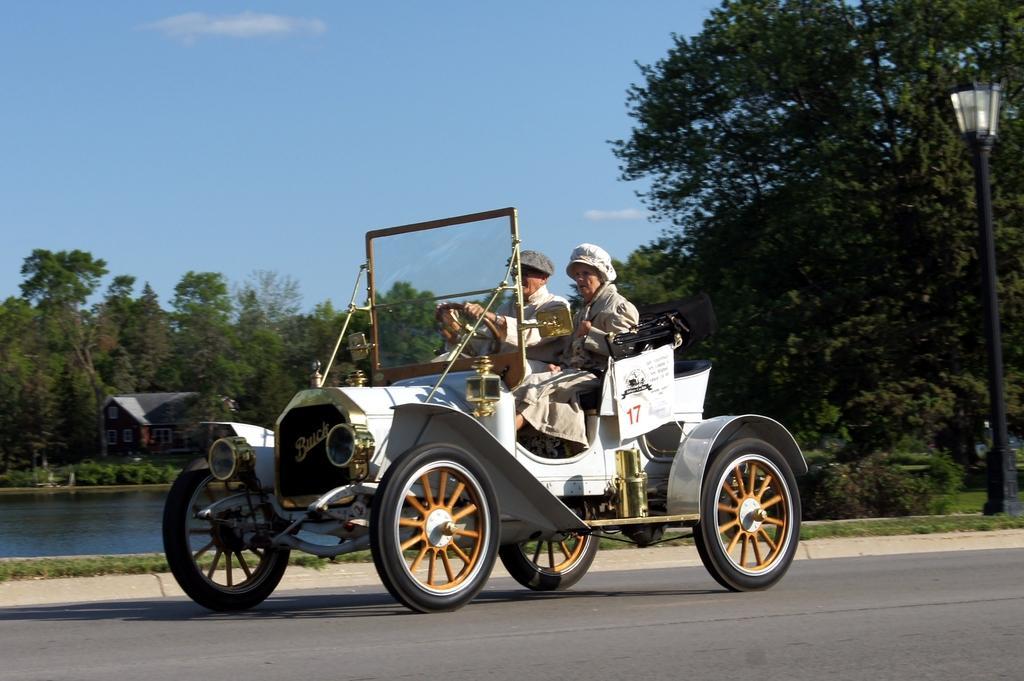Describe this image in one or two sentences. In the center of the image there is a vehicle and we can see a man and a lady sitting in the vehicle. In the background there is a pole, trees and a shed. At the bottom there is a lake and we can see a road. At the top there is sky. 